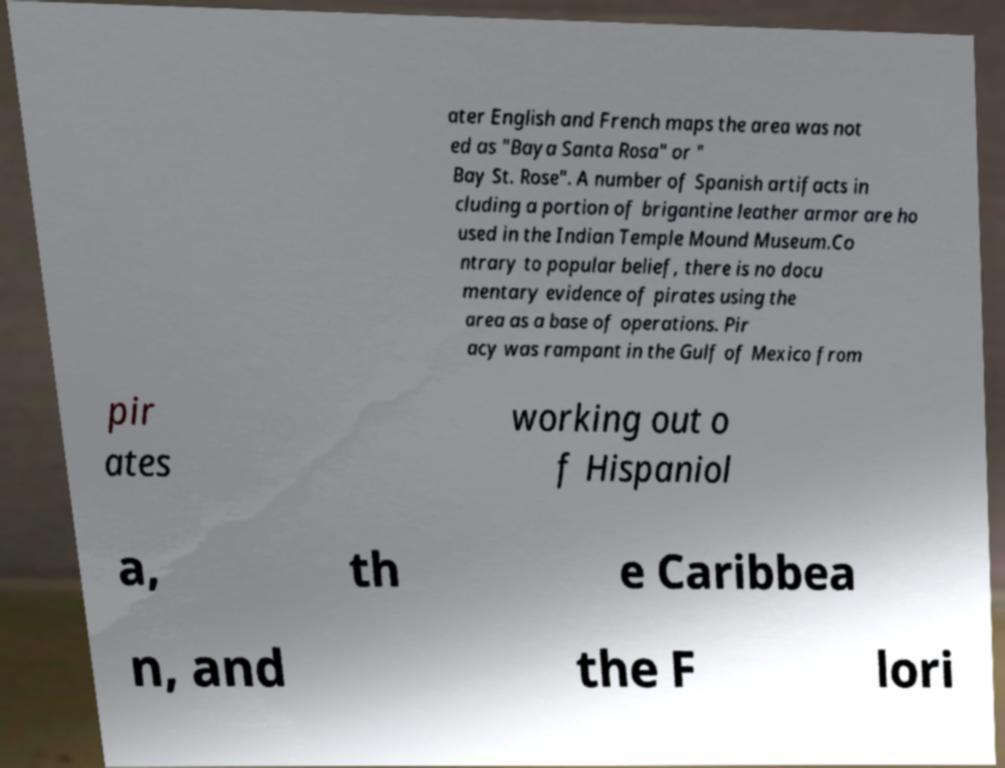Please identify and transcribe the text found in this image. ater English and French maps the area was not ed as "Baya Santa Rosa" or " Bay St. Rose". A number of Spanish artifacts in cluding a portion of brigantine leather armor are ho used in the Indian Temple Mound Museum.Co ntrary to popular belief, there is no docu mentary evidence of pirates using the area as a base of operations. Pir acy was rampant in the Gulf of Mexico from pir ates working out o f Hispaniol a, th e Caribbea n, and the F lori 